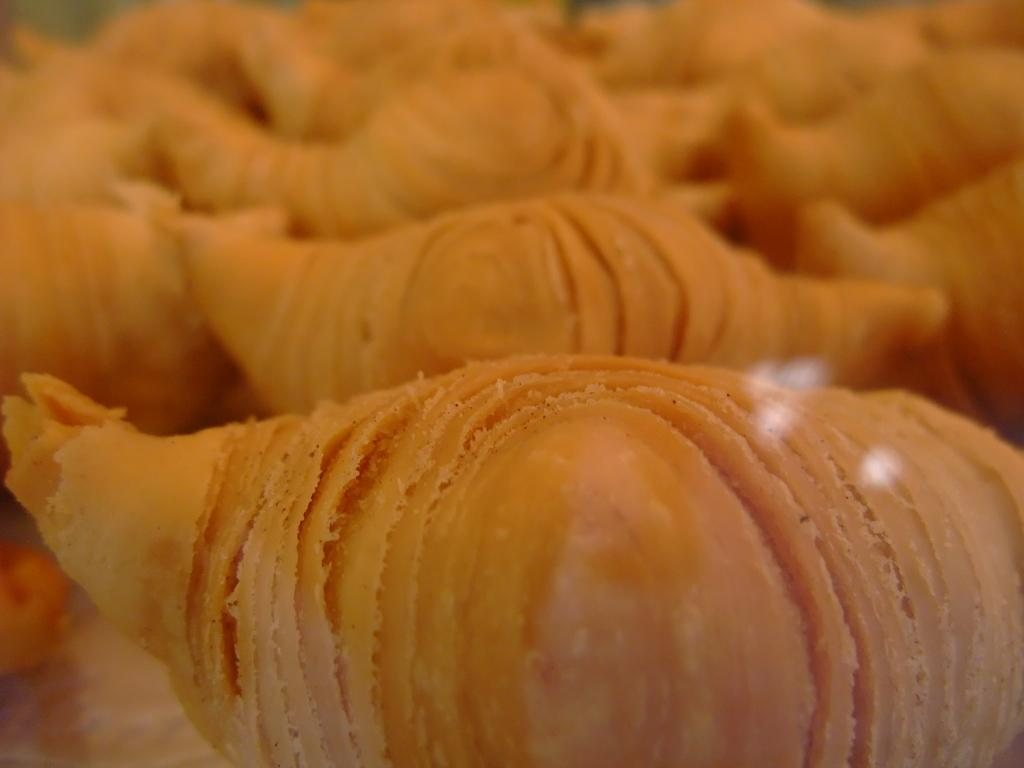What type of food is visible in the image? There is a sweet bread in the image. Where is the sweet bread located? The sweet bread is on a table. What type of jar is visible on the table next to the sweet bread? There is no jar present in the image; only the sweet bread is visible on the table. 